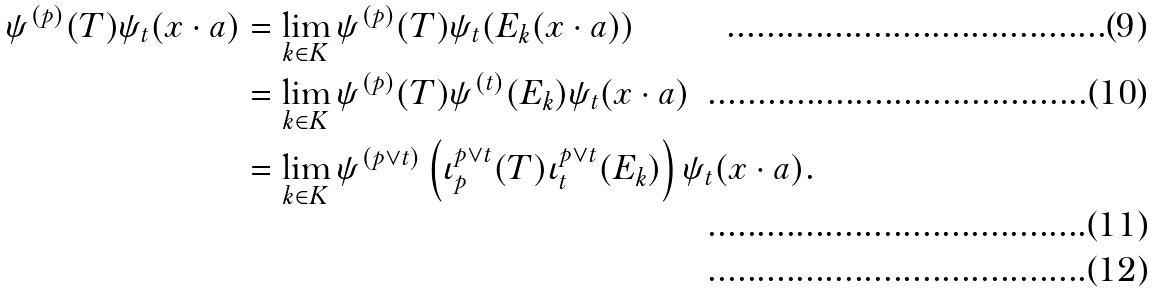<formula> <loc_0><loc_0><loc_500><loc_500>\psi ^ { ( p ) } ( T ) \psi _ { t } ( x \cdot a ) & = \lim _ { k \in K } \psi ^ { ( p ) } ( T ) \psi _ { t } ( E _ { k } ( x \cdot a ) ) \\ & = \lim _ { k \in K } \psi ^ { ( p ) } ( T ) \psi ^ { ( t ) } ( E _ { k } ) \psi _ { t } ( x \cdot a ) \\ & = \lim _ { k \in K } \psi ^ { ( p \vee t ) } \left ( \iota ^ { p \vee t } _ { p } ( T ) \iota ^ { p \vee t } _ { t } ( E _ { k } ) \right ) \psi _ { t } ( x \cdot a ) . \\</formula> 